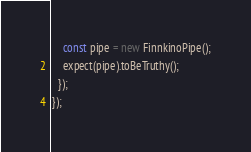Convert code to text. <code><loc_0><loc_0><loc_500><loc_500><_TypeScript_>    const pipe = new FinnkinoPipe();
    expect(pipe).toBeTruthy();
  });
});

</code> 